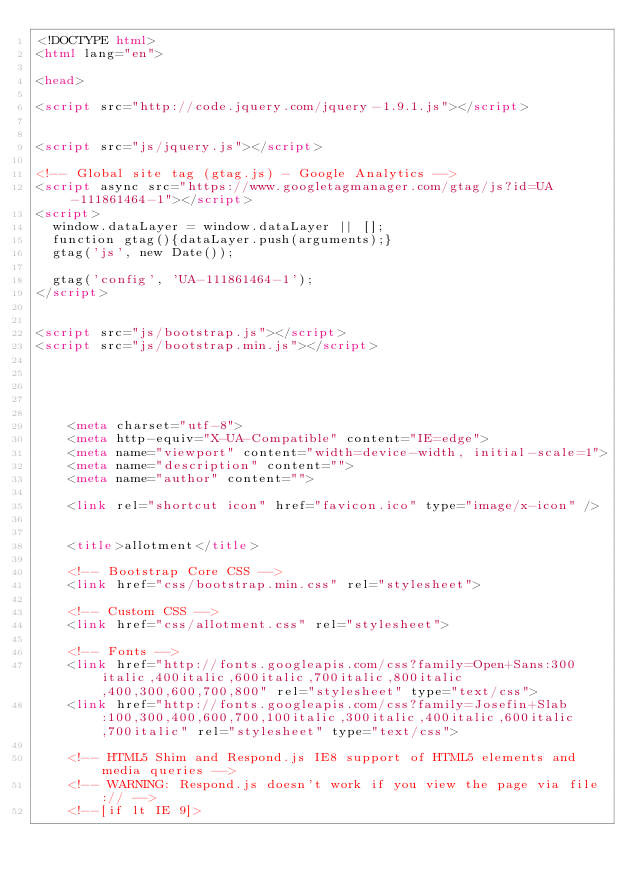<code> <loc_0><loc_0><loc_500><loc_500><_HTML_><!DOCTYPE html>
<html lang="en">

<head>

<script src="http://code.jquery.com/jquery-1.9.1.js"></script>


<script src="js/jquery.js"></script>

<!-- Global site tag (gtag.js) - Google Analytics -->
<script async src="https://www.googletagmanager.com/gtag/js?id=UA-111861464-1"></script>
<script>
  window.dataLayer = window.dataLayer || [];
  function gtag(){dataLayer.push(arguments);}
  gtag('js', new Date());

  gtag('config', 'UA-111861464-1');
</script>


<script src="js/bootstrap.js"></script> 
<script src="js/bootstrap.min.js"></script>





    <meta charset="utf-8">
    <meta http-equiv="X-UA-Compatible" content="IE=edge">
    <meta name="viewport" content="width=device-width, initial-scale=1">
    <meta name="description" content="">
    <meta name="author" content="">

    <link rel="shortcut icon" href="favicon.ico" type="image/x-icon" />


    <title>allotment</title>

    <!-- Bootstrap Core CSS -->
    <link href="css/bootstrap.min.css" rel="stylesheet">

    <!-- Custom CSS -->
    <link href="css/allotment.css" rel="stylesheet">

    <!-- Fonts -->
    <link href="http://fonts.googleapis.com/css?family=Open+Sans:300italic,400italic,600italic,700italic,800italic,400,300,600,700,800" rel="stylesheet" type="text/css">
    <link href="http://fonts.googleapis.com/css?family=Josefin+Slab:100,300,400,600,700,100italic,300italic,400italic,600italic,700italic" rel="stylesheet" type="text/css">

    <!-- HTML5 Shim and Respond.js IE8 support of HTML5 elements and media queries -->
    <!-- WARNING: Respond.js doesn't work if you view the page via file:// -->
    <!--[if lt IE 9]></code> 